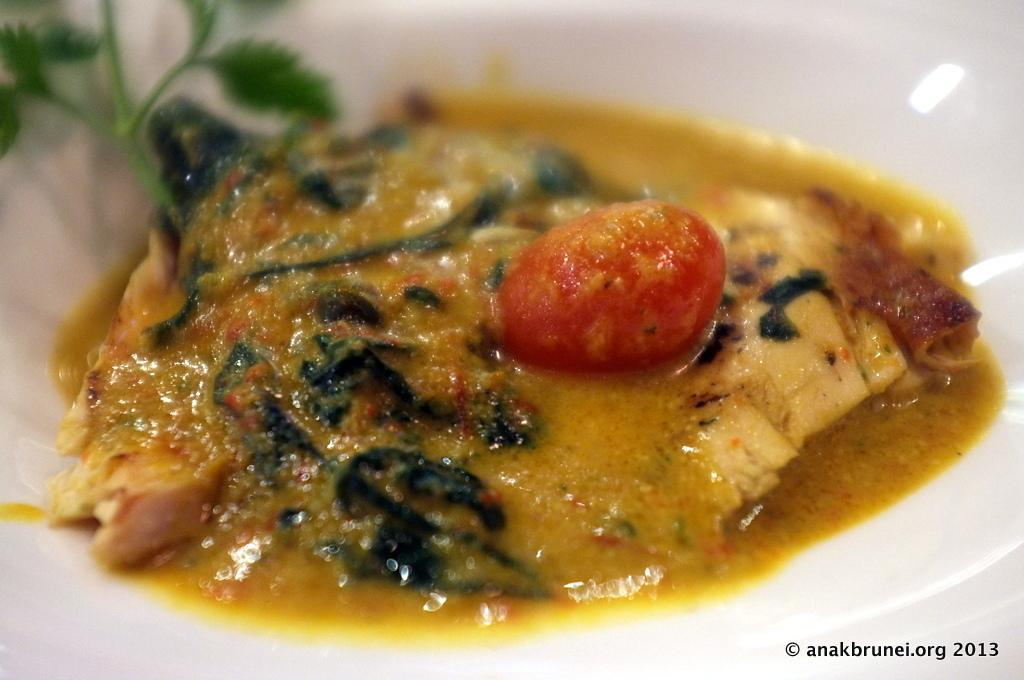What is the main subject of the image? There is a food item in the image. How is the food item presented in the image? The food item is placed on a plate. What type of car can be seen in the background of the image? There is no car present in the image; it only features a food item placed on a plate. 